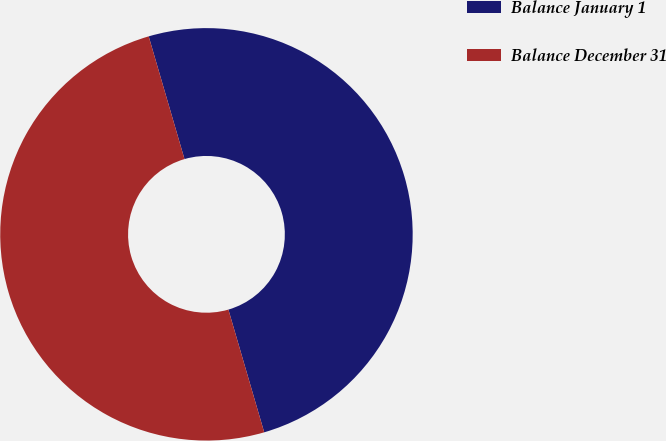<chart> <loc_0><loc_0><loc_500><loc_500><pie_chart><fcel>Balance January 1<fcel>Balance December 31<nl><fcel>50.0%<fcel>50.0%<nl></chart> 